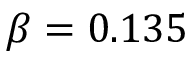Convert formula to latex. <formula><loc_0><loc_0><loc_500><loc_500>\beta = 0 . 1 3 5</formula> 